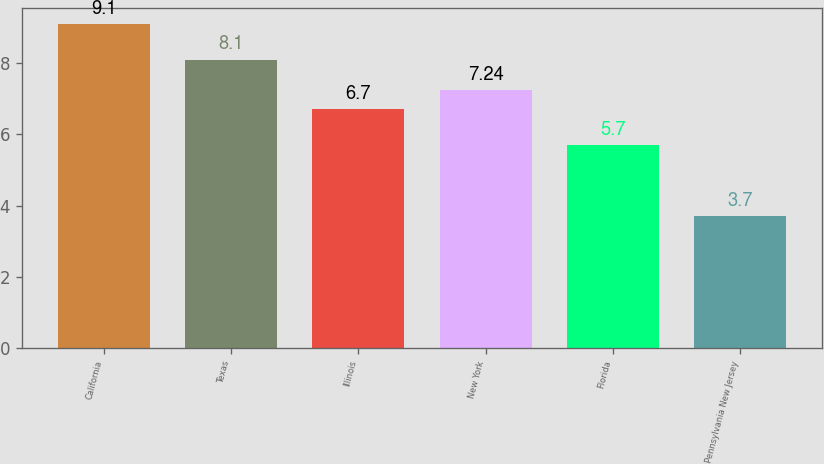<chart> <loc_0><loc_0><loc_500><loc_500><bar_chart><fcel>California<fcel>Texas<fcel>Illinois<fcel>New York<fcel>Florida<fcel>Pennsylvania New Jersey<nl><fcel>9.1<fcel>8.1<fcel>6.7<fcel>7.24<fcel>5.7<fcel>3.7<nl></chart> 